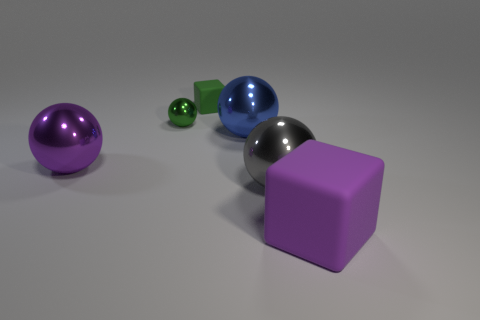How many other objects are the same material as the green cube?
Offer a very short reply. 1. There is a purple thing behind the big purple object right of the large gray thing that is to the left of the big purple rubber object; what is it made of?
Offer a terse response. Metal. Is the tiny block made of the same material as the purple cube?
Ensure brevity in your answer.  Yes. How many cylinders are either large things or small green metallic objects?
Your response must be concise. 0. The sphere on the right side of the large blue metal object is what color?
Provide a short and direct response. Gray. What number of rubber objects are tiny brown objects or blue objects?
Offer a terse response. 0. The large purple object to the right of the green metal thing to the left of the tiny matte cube is made of what material?
Give a very brief answer. Rubber. There is a tiny object that is the same color as the tiny shiny sphere; what is its material?
Provide a short and direct response. Rubber. What color is the tiny shiny sphere?
Your answer should be compact. Green. There is a big purple object behind the big rubber cube; are there any tiny green spheres behind it?
Keep it short and to the point. Yes. 